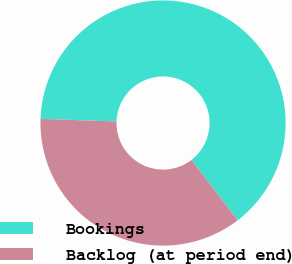<chart> <loc_0><loc_0><loc_500><loc_500><pie_chart><fcel>Bookings<fcel>Backlog (at period end)<nl><fcel>64.02%<fcel>35.98%<nl></chart> 